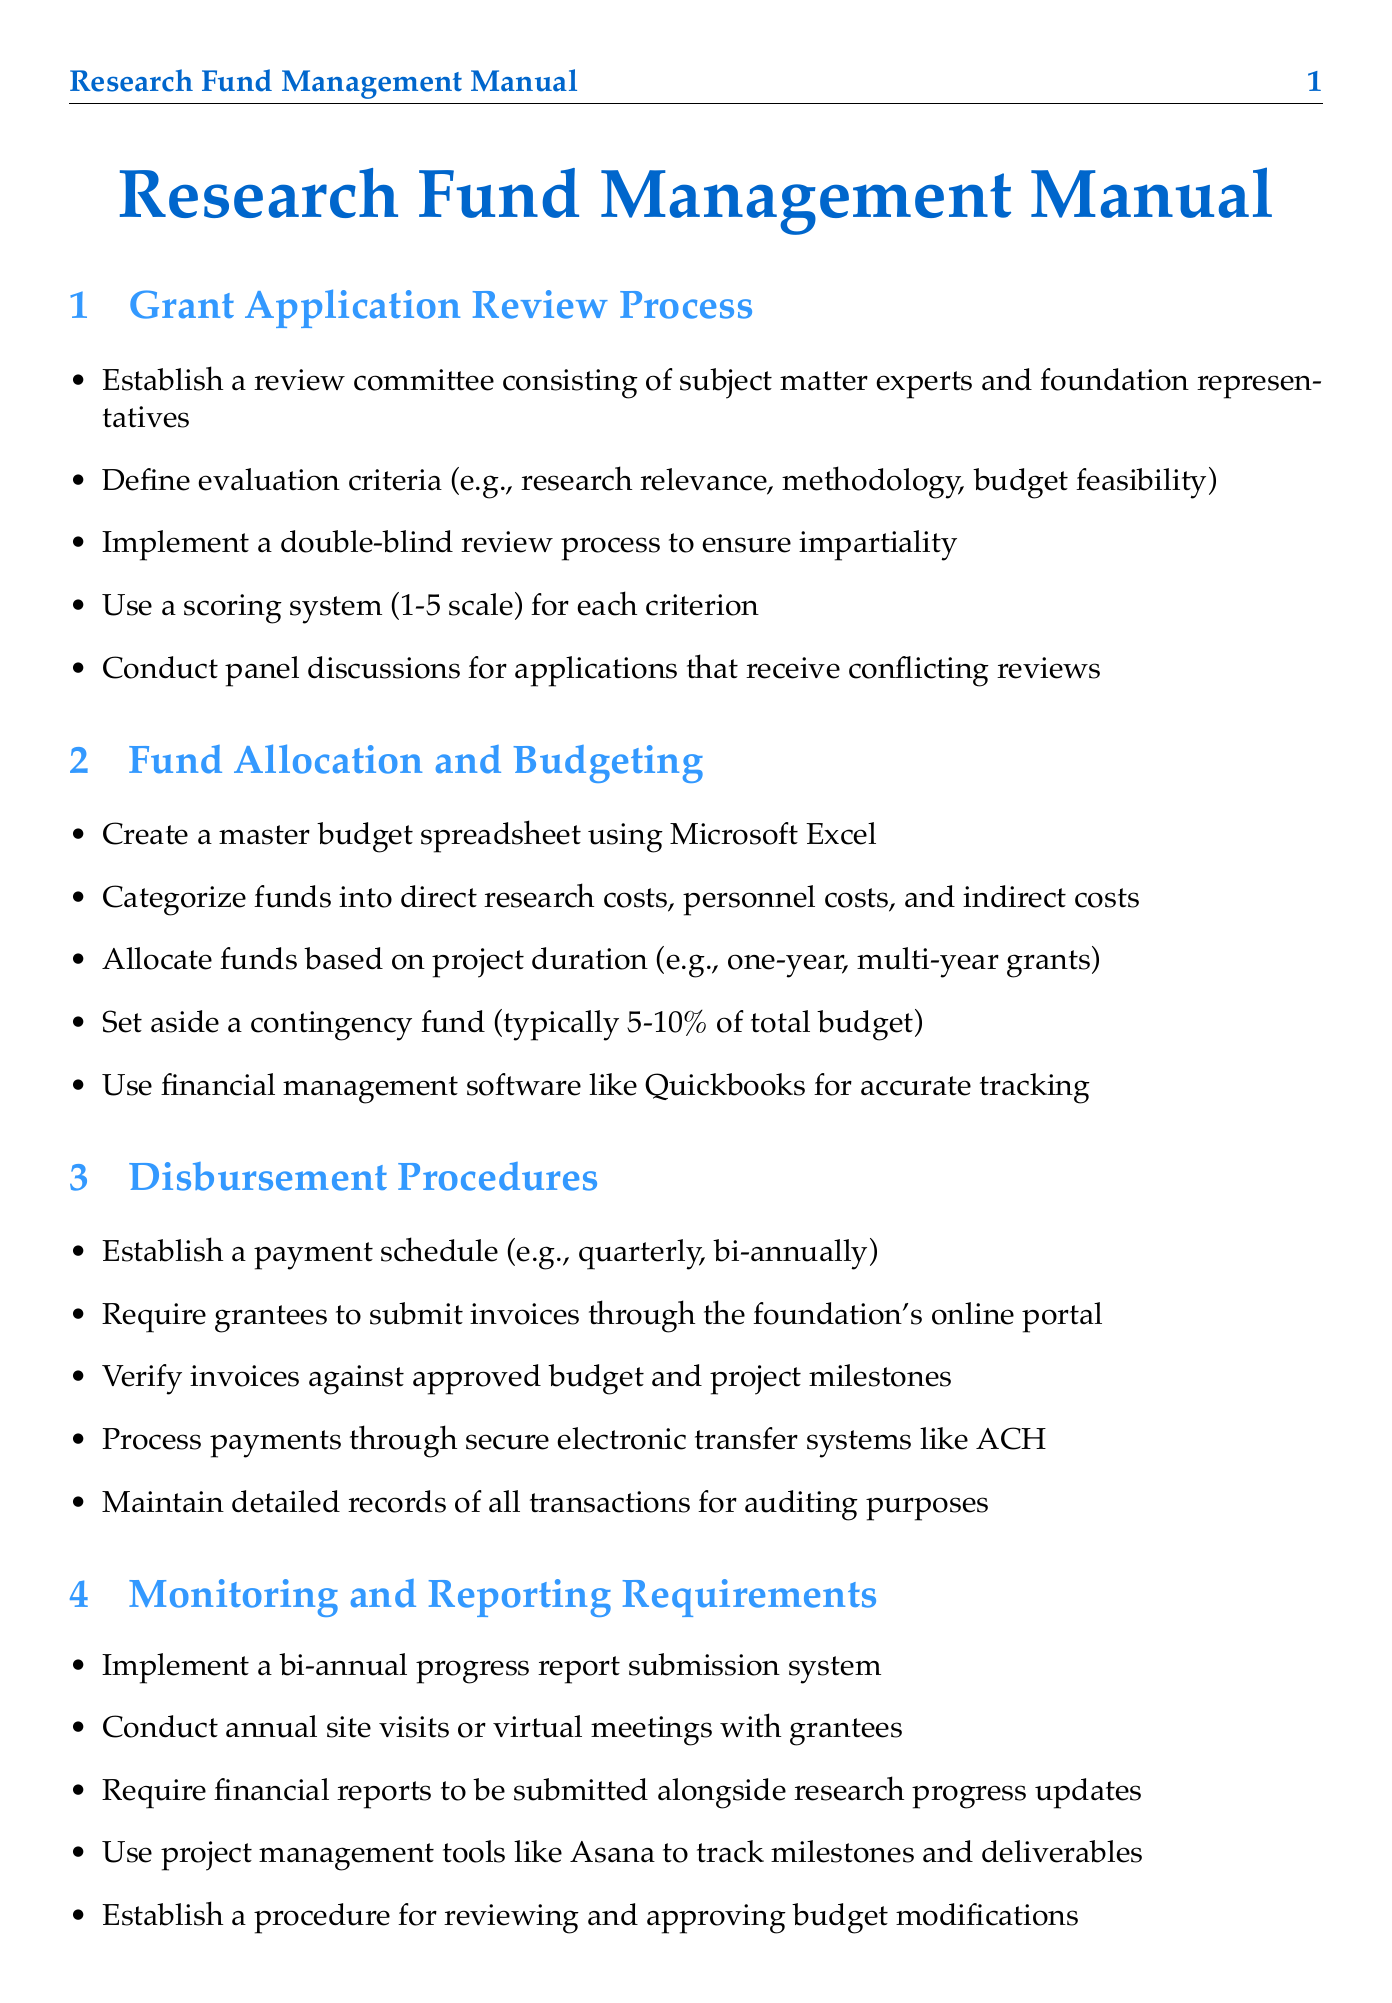What is the primary purpose of the Grants Management Manual? The primary purpose is to outline detailed procedures for managing and disbursing research funds to economists.
Answer: Managing and disbursing research funds Who is responsible for overseeing the overall research strategy? Dr. Emily Chen is mentioned as the Chief Economist who oversees the research strategy.
Answer: Dr. Emily Chen What percentage of the total budget is set aside as a contingency fund? The manual specifies that a contingency fund of typically 5-10% of the total budget is set aside.
Answer: 5-10% What is the timeframe for submitting a final comprehensive report upon project completion? The manual states that the final report must be submitted within 90 days of project completion.
Answer: 90 days What is the scoring system used during the grant application review? The manual describes a scoring system that uses a 1-5 scale for each evaluation criterion.
Answer: 1-5 scale Which software is recommended for grants management? The manual mentions Fluxx as a grants management software for streamlining the grant lifecycle.
Answer: Fluxx What is required from grantees alongside their research progress updates? Grantees are required to submit financial reports alongside their progress updates.
Answer: Financial reports What role does Sarah Thompson perform in the foundation? Sarah Thompson serves as the Grants Management Specialist, handling day-to-day grant administration.
Answer: Grants Management Specialist What type of approval must be obtained when applicable? The manual states that grantees must obtain Institutional Review Board (IRB) approval when applicable.
Answer: Institutional Review Board (IRB) approval 